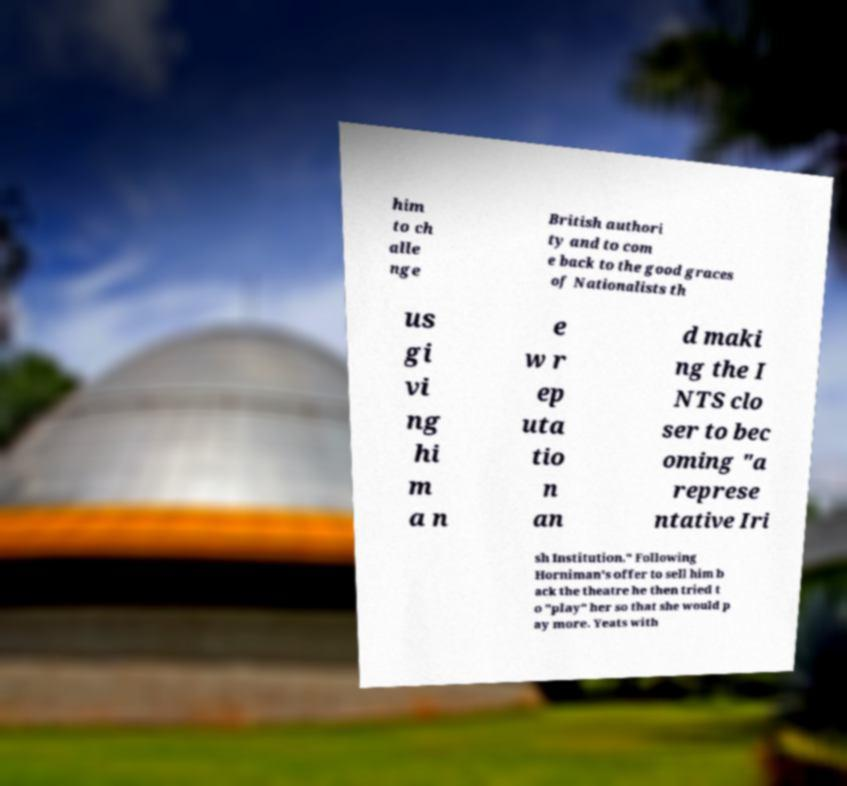Please read and relay the text visible in this image. What does it say? him to ch alle nge British authori ty and to com e back to the good graces of Nationalists th us gi vi ng hi m a n e w r ep uta tio n an d maki ng the I NTS clo ser to bec oming "a represe ntative Iri sh Institution." Following Horniman's offer to sell him b ack the theatre he then tried t o "play" her so that she would p ay more. Yeats with 